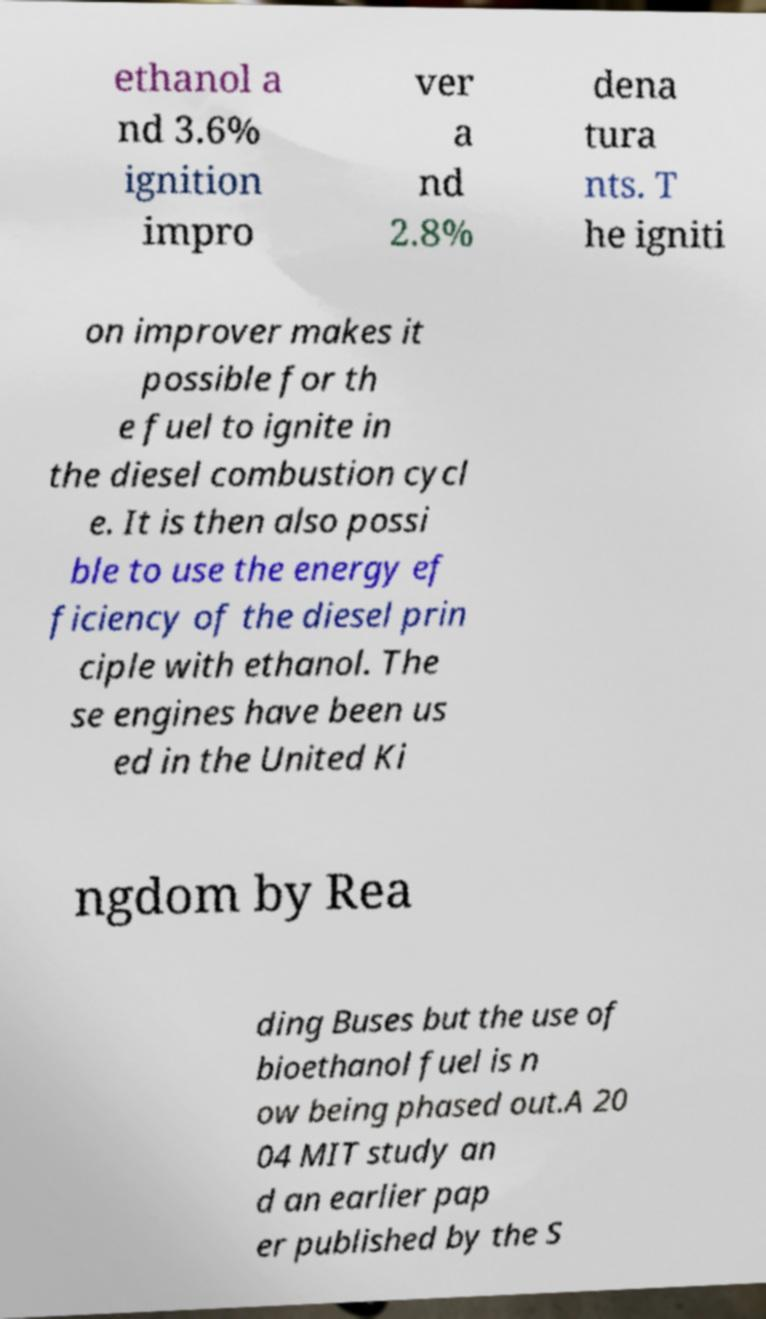I need the written content from this picture converted into text. Can you do that? ethanol a nd 3.6% ignition impro ver a nd 2.8% dena tura nts. T he igniti on improver makes it possible for th e fuel to ignite in the diesel combustion cycl e. It is then also possi ble to use the energy ef ficiency of the diesel prin ciple with ethanol. The se engines have been us ed in the United Ki ngdom by Rea ding Buses but the use of bioethanol fuel is n ow being phased out.A 20 04 MIT study an d an earlier pap er published by the S 